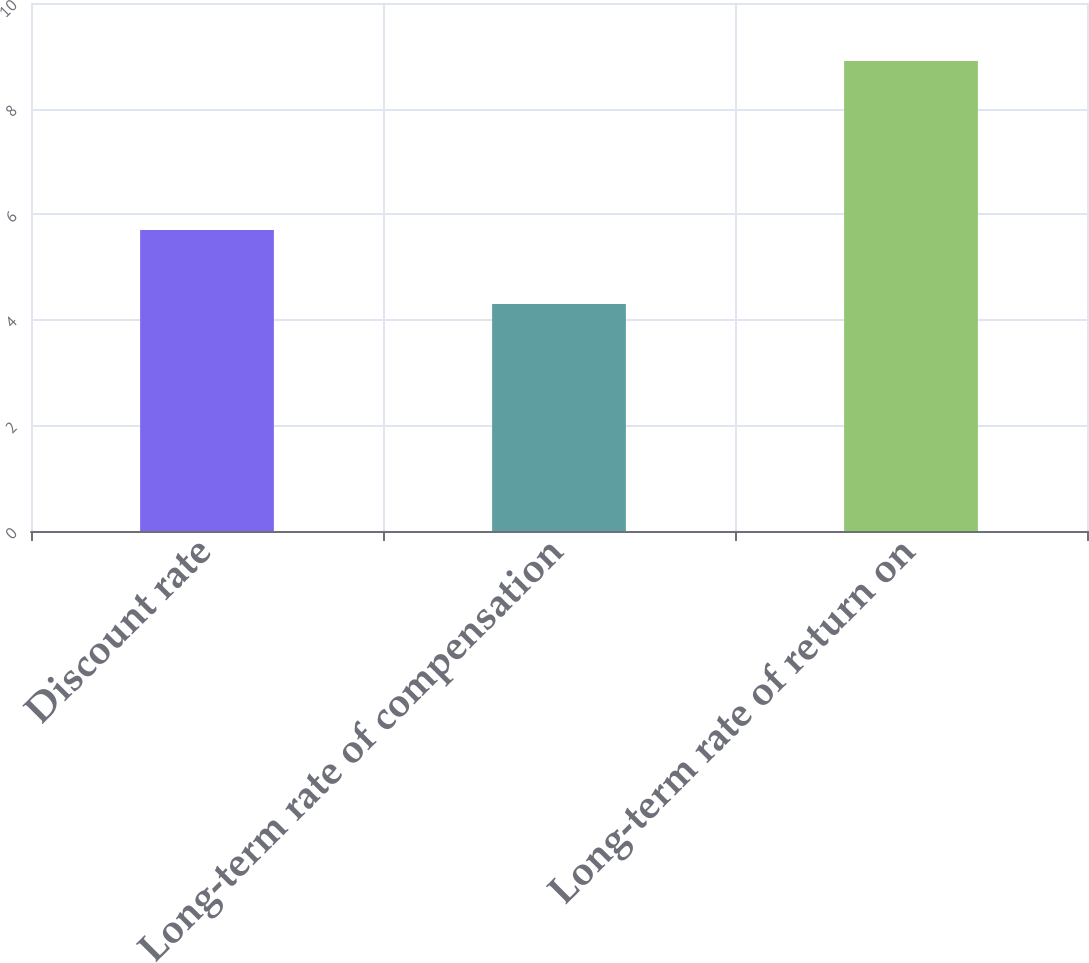Convert chart. <chart><loc_0><loc_0><loc_500><loc_500><bar_chart><fcel>Discount rate<fcel>Long-term rate of compensation<fcel>Long-term rate of return on<nl><fcel>5.7<fcel>4.3<fcel>8.9<nl></chart> 